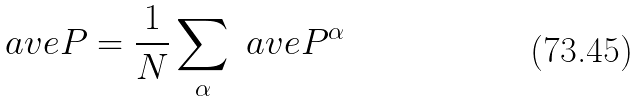<formula> <loc_0><loc_0><loc_500><loc_500>\ a v e { P } = \frac { 1 } { N } \sum _ { \alpha } \ a v e { P ^ { \alpha } }</formula> 